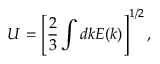<formula> <loc_0><loc_0><loc_500><loc_500>U = \left [ \frac { 2 } { 3 } \int d k E ( k ) \right ] ^ { 1 / 2 } ,</formula> 